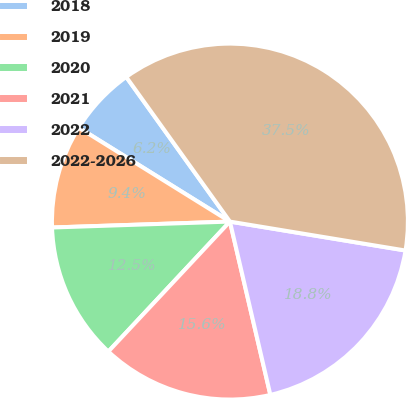Convert chart to OTSL. <chart><loc_0><loc_0><loc_500><loc_500><pie_chart><fcel>2018<fcel>2019<fcel>2020<fcel>2021<fcel>2022<fcel>2022-2026<nl><fcel>6.25%<fcel>9.38%<fcel>12.5%<fcel>15.62%<fcel>18.75%<fcel>37.5%<nl></chart> 